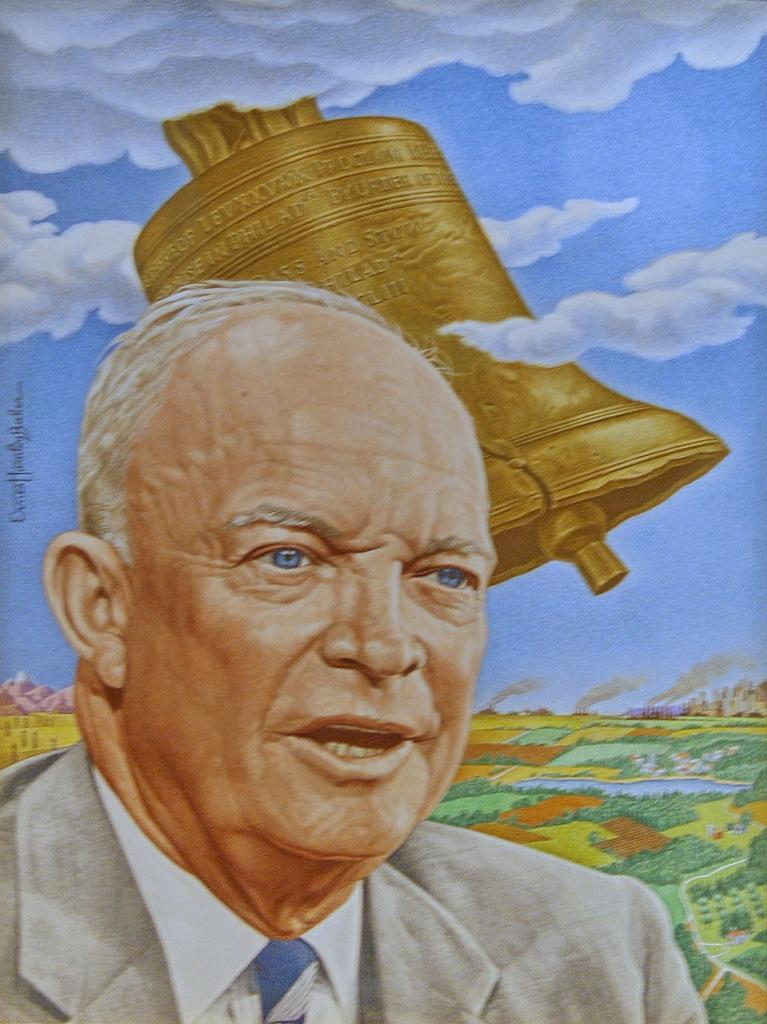What type of artwork is depicted in the image? The image appears to be a painting. Can you describe the person at the bottom of the image? There is a person speaking at the bottom of the image. What type of vegetation is on the right side of the image? There are trees on the right side of the image. What is the unusual object in the sky at the top of the image? There is a bell in the sky at the top of the image. How many rings are visible on the person's fingers in the image? There are no rings visible on the person's fingers in the image. What day of the week is depicted in the image? The image does not depict a specific day of the week. What musical instrument is being played by the person in the image? The person in the image is speaking, not playing a musical instrument. 